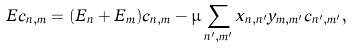<formula> <loc_0><loc_0><loc_500><loc_500>E c _ { n , m } = ( E _ { n } + E _ { m } ) c _ { n , m } - \mu \sum _ { n ^ { \prime } , m ^ { \prime } } x _ { n , n ^ { \prime } } y _ { m , m ^ { \prime } } c _ { n ^ { \prime } , m ^ { \prime } } ,</formula> 